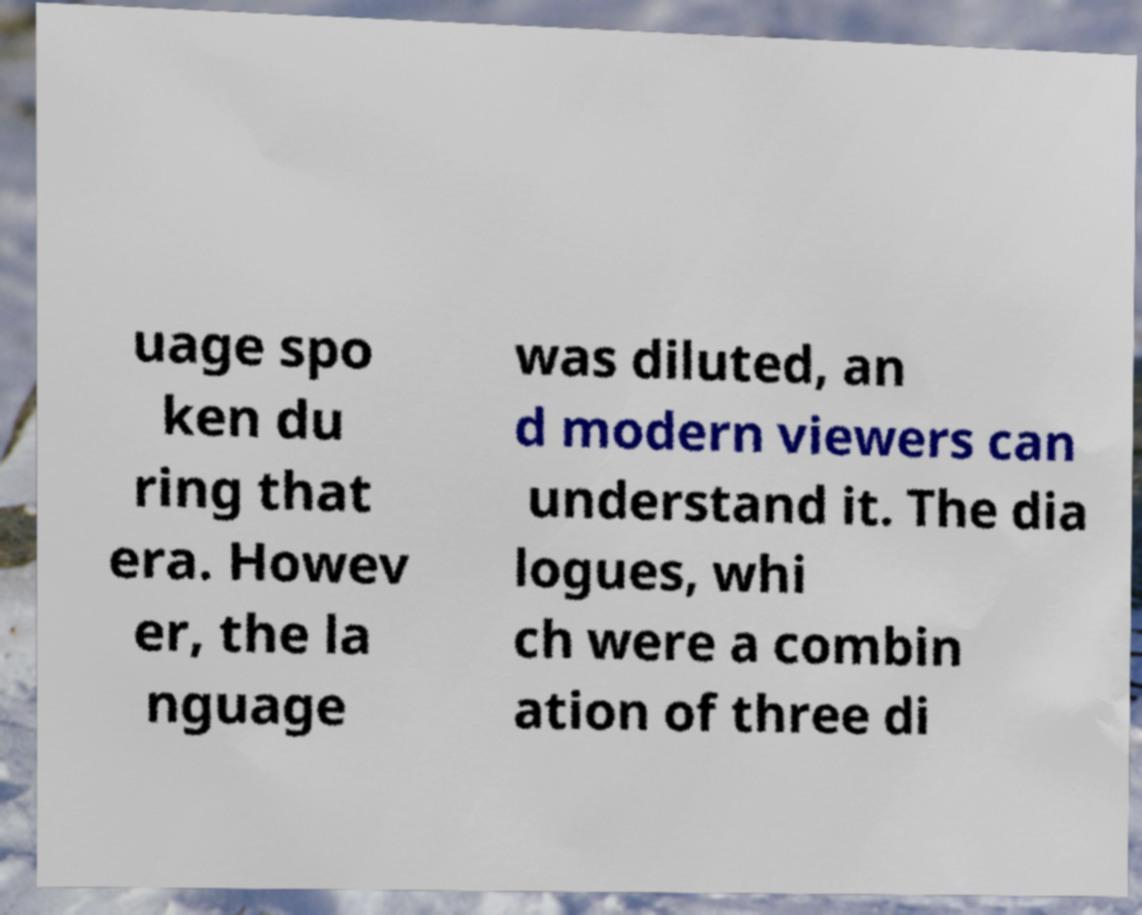Can you accurately transcribe the text from the provided image for me? uage spo ken du ring that era. Howev er, the la nguage was diluted, an d modern viewers can understand it. The dia logues, whi ch were a combin ation of three di 